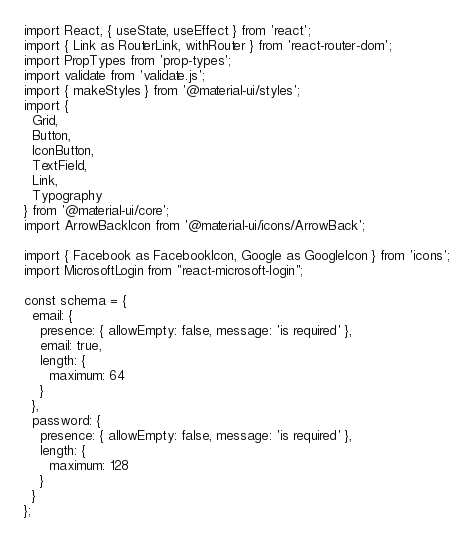<code> <loc_0><loc_0><loc_500><loc_500><_JavaScript_>import React, { useState, useEffect } from 'react';
import { Link as RouterLink, withRouter } from 'react-router-dom';
import PropTypes from 'prop-types';
import validate from 'validate.js';
import { makeStyles } from '@material-ui/styles';
import {
  Grid,
  Button,
  IconButton,
  TextField,
  Link,
  Typography
} from '@material-ui/core';
import ArrowBackIcon from '@material-ui/icons/ArrowBack';

import { Facebook as FacebookIcon, Google as GoogleIcon } from 'icons';
import MicrosoftLogin from "react-microsoft-login";

const schema = {
  email: {
    presence: { allowEmpty: false, message: 'is required' },
    email: true,
    length: {
      maximum: 64
    }
  },
  password: {
    presence: { allowEmpty: false, message: 'is required' },
    length: {
      maximum: 128
    }
  }
};
</code> 